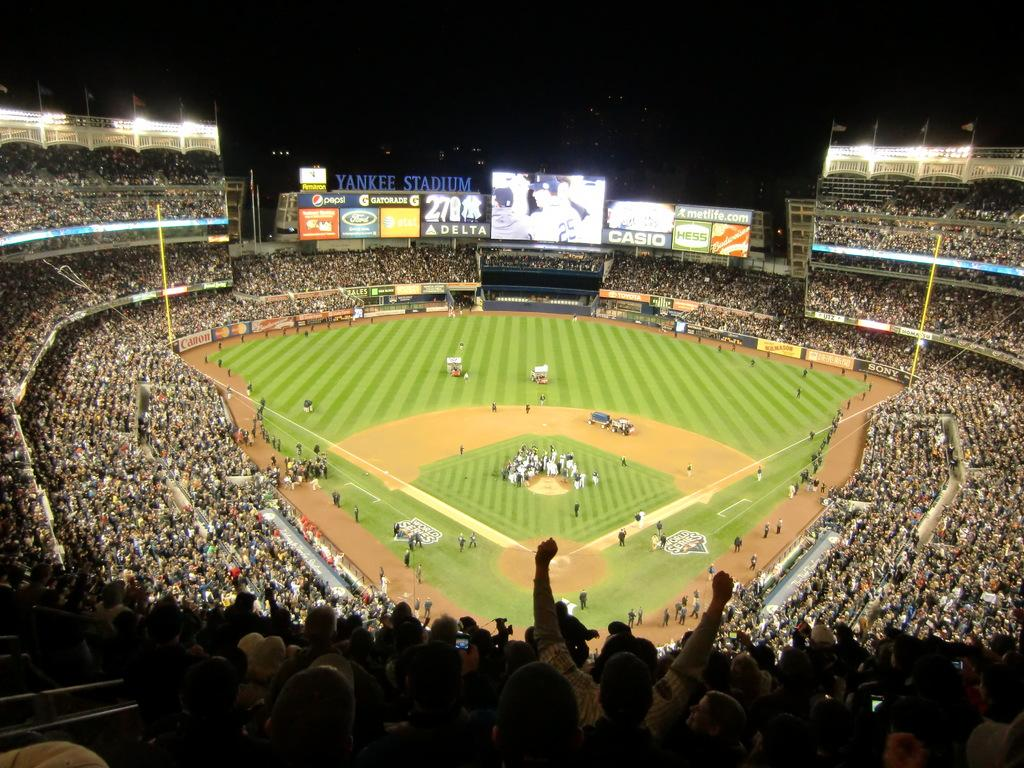<image>
Summarize the visual content of the image. the brand Delta can be seen in the outfield at the game 